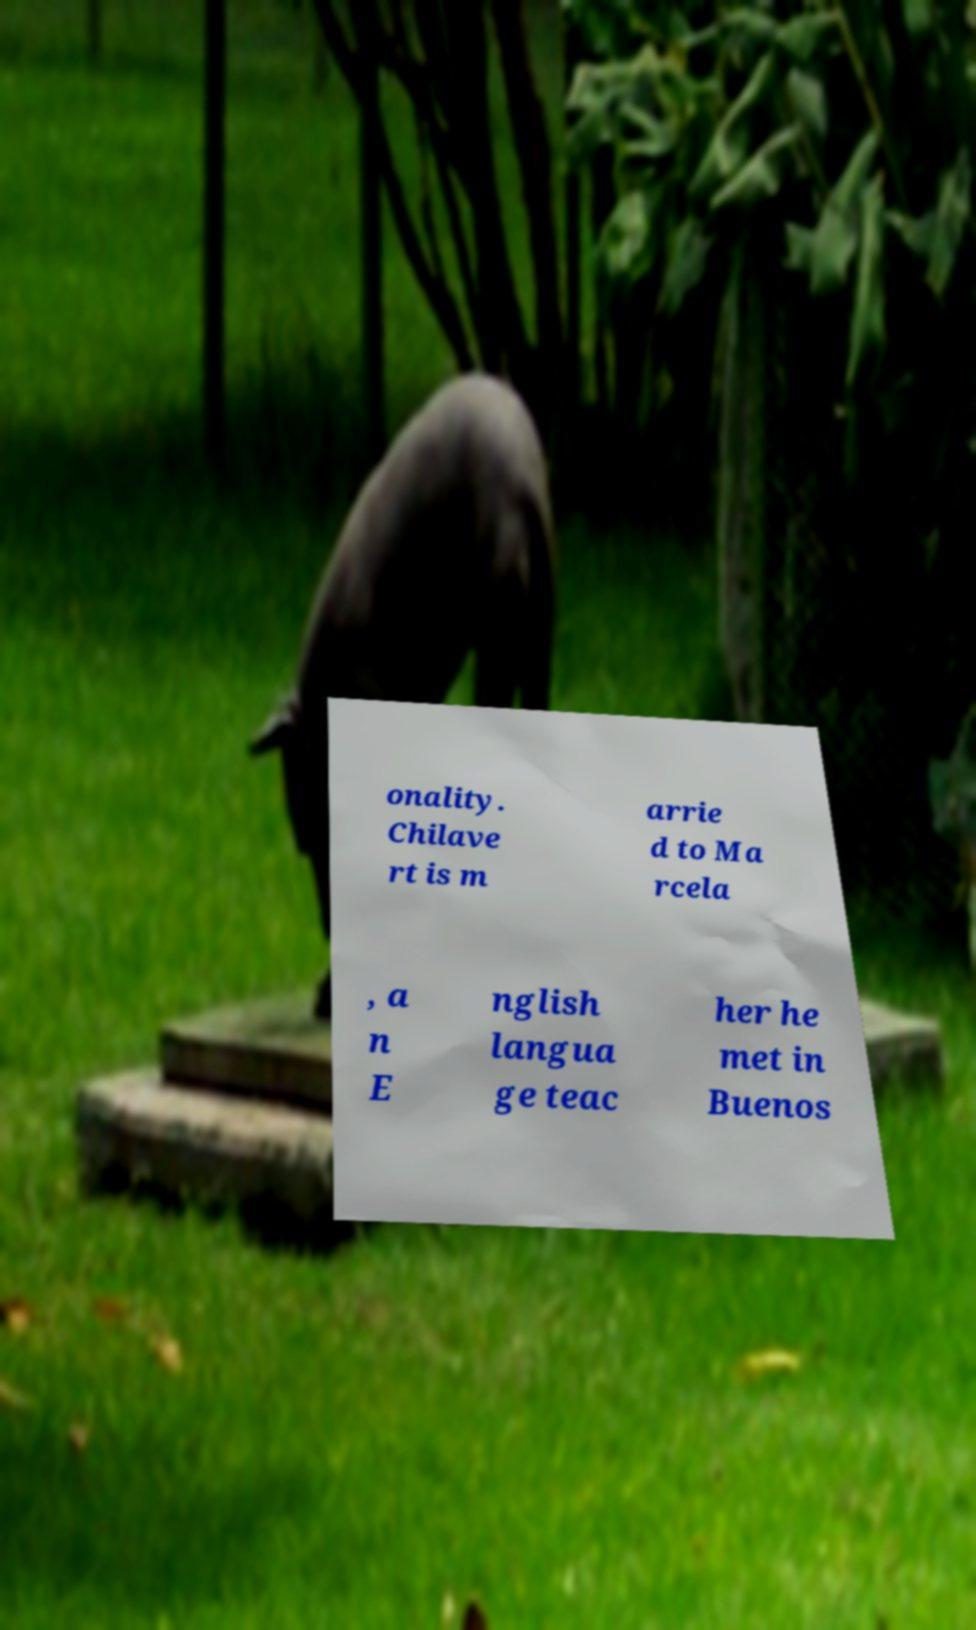Please identify and transcribe the text found in this image. onality. Chilave rt is m arrie d to Ma rcela , a n E nglish langua ge teac her he met in Buenos 